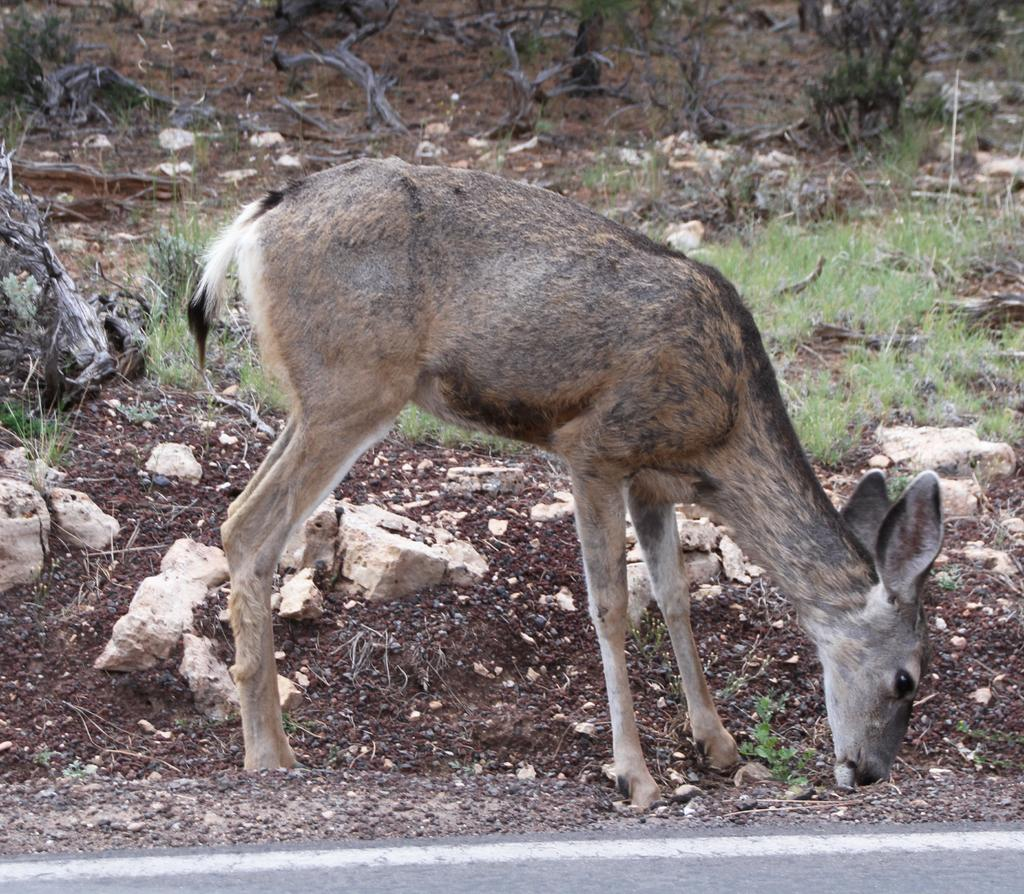What type of animal can be seen in the image? There is an animal in the image, but its specific type cannot be determined from the provided facts. What kind of man-made structure is visible in the image? There is no man-made structure like a house mentioned in the provided facts. What is the terrain like in the image? The terrain in the image includes soil, stones, and grass. What natural element is present in the image? There is a tree branch in the image. What are the brothers doing in the image? There is no mention of brothers or any human figures in the provided facts, so we cannot answer this question. 